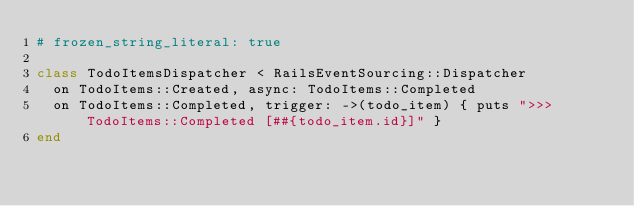Convert code to text. <code><loc_0><loc_0><loc_500><loc_500><_Ruby_># frozen_string_literal: true

class TodoItemsDispatcher < RailsEventSourcing::Dispatcher
  on TodoItems::Created, async: TodoItems::Completed
  on TodoItems::Completed, trigger: ->(todo_item) { puts ">>> TodoItems::Completed [##{todo_item.id}]" }
end
</code> 